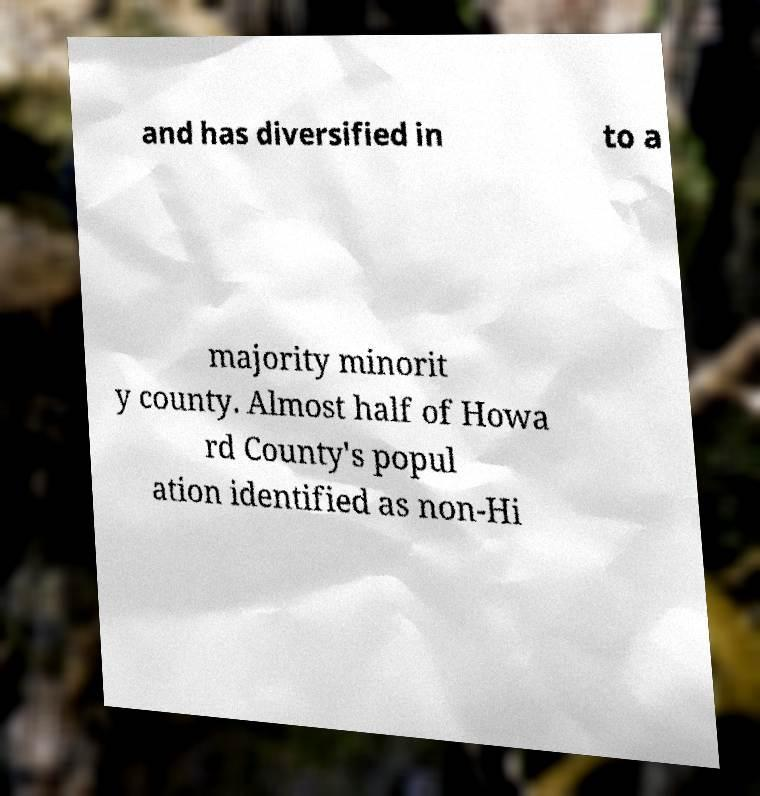Can you explain the significance of Howard County becoming a majority minority county? Becoming a majority minority county indicates a significant demographic shift where no single ethnic or racial group makes up the majority of the population. This change may impact local culture, politics, and social dynamics, shedding light on growing diversity and potentially affecting policy decisions and community relations. 